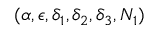<formula> <loc_0><loc_0><loc_500><loc_500>( \alpha , \epsilon , \delta _ { 1 } , \delta _ { 2 } , \delta _ { 3 } , N _ { 1 } )</formula> 